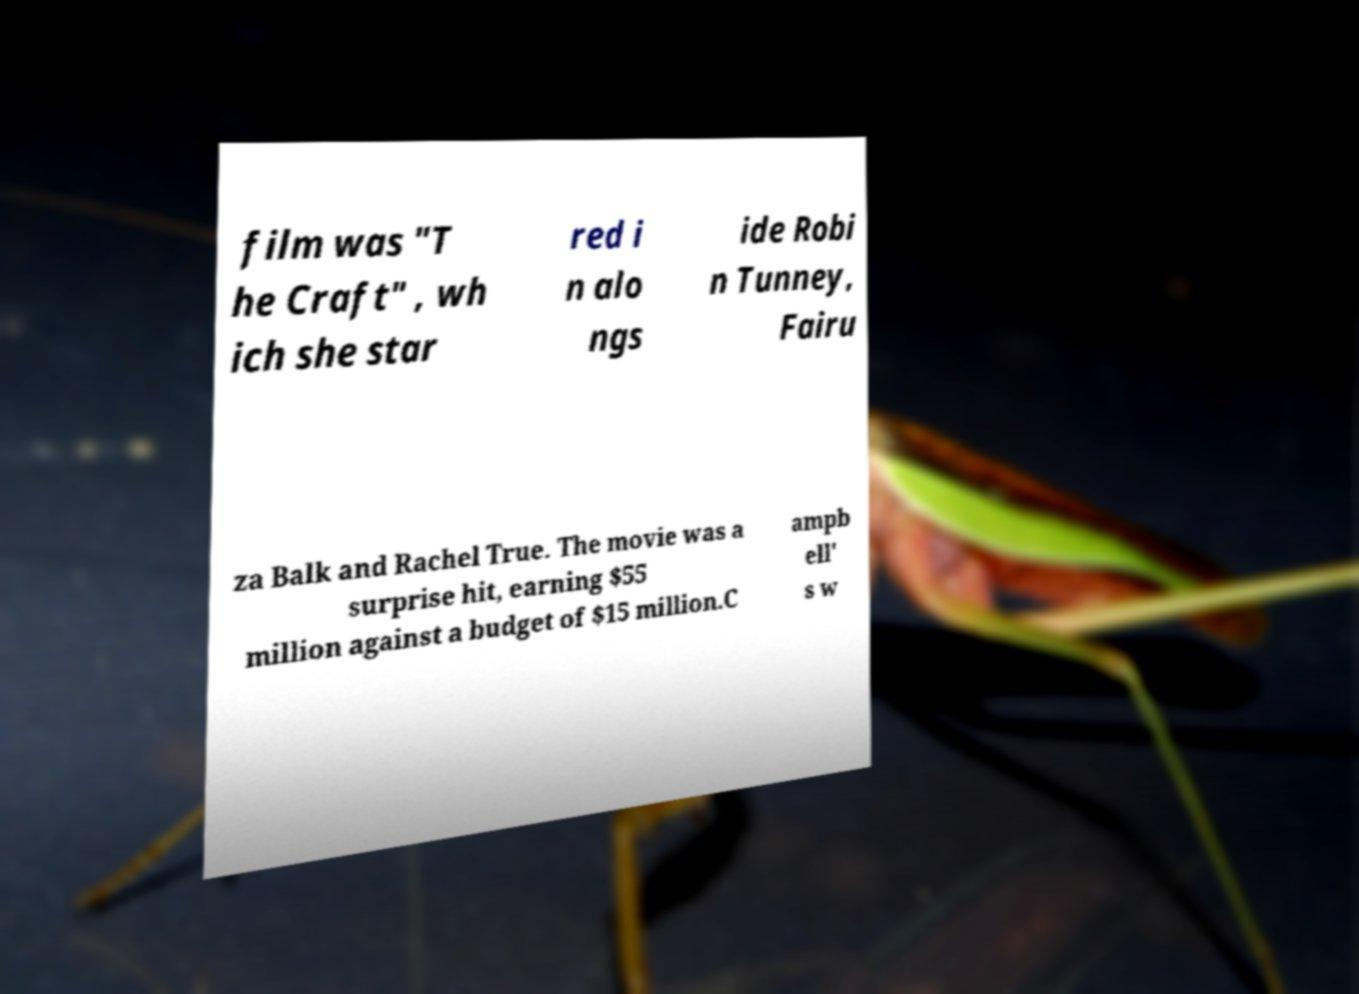There's text embedded in this image that I need extracted. Can you transcribe it verbatim? film was "T he Craft" , wh ich she star red i n alo ngs ide Robi n Tunney, Fairu za Balk and Rachel True. The movie was a surprise hit, earning $55 million against a budget of $15 million.C ampb ell' s w 